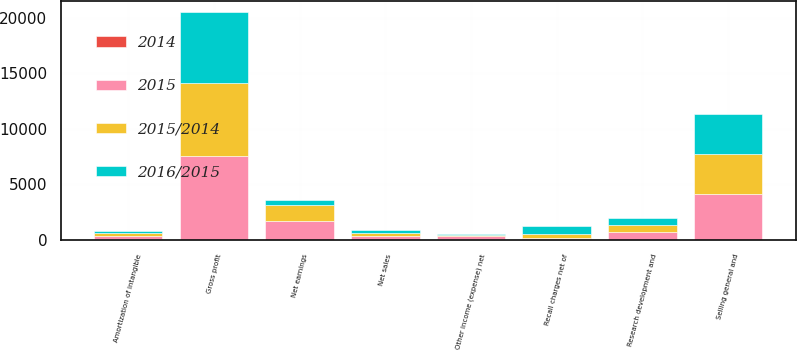<chart> <loc_0><loc_0><loc_500><loc_500><stacked_bar_chart><ecel><fcel>Net sales<fcel>Gross profit<fcel>Research development and<fcel>Selling general and<fcel>Recall charges net of<fcel>Amortization of intangible<fcel>Other income (expense) net<fcel>Net earnings<nl><fcel>2015<fcel>296<fcel>7495<fcel>715<fcel>4137<fcel>158<fcel>319<fcel>245<fcel>1647<nl><fcel>2015/2014<fcel>296<fcel>6602<fcel>625<fcel>3610<fcel>296<fcel>210<fcel>126<fcel>1439<nl><fcel>2016/2015<fcel>296<fcel>6356<fcel>614<fcel>3547<fcel>761<fcel>188<fcel>86<fcel>515<nl><fcel>2014<fcel>13.9<fcel>13.5<fcel>14.4<fcel>14.6<fcel>46.6<fcel>51.9<fcel>94.4<fcel>14.5<nl></chart> 